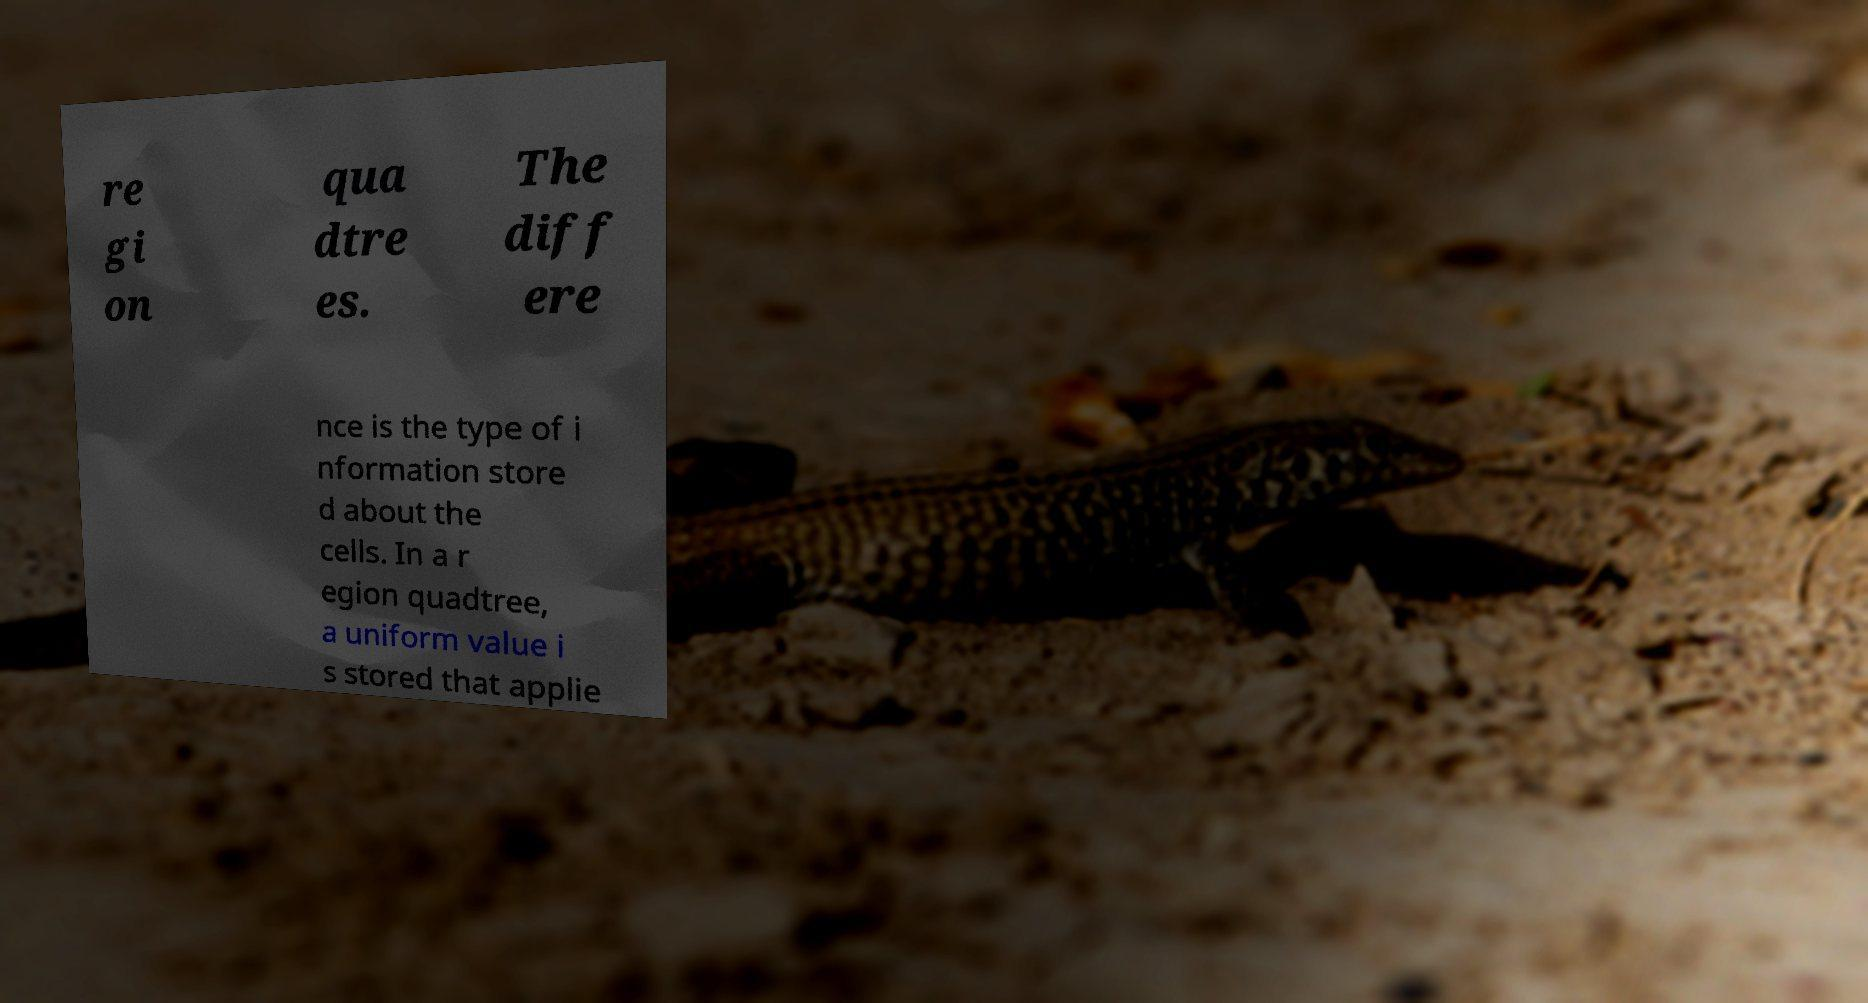Please identify and transcribe the text found in this image. re gi on qua dtre es. The diff ere nce is the type of i nformation store d about the cells. In a r egion quadtree, a uniform value i s stored that applie 